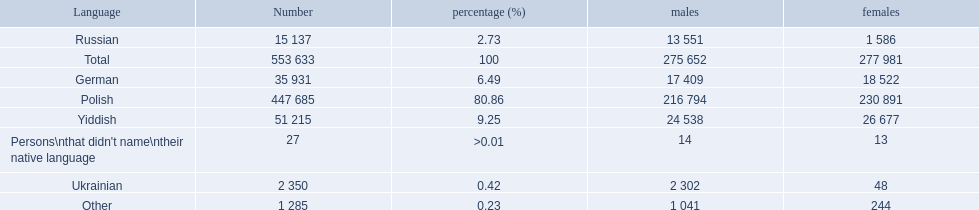What was the highest percentage of one language spoken by the plock governorate? 80.86. What language was spoken by 80.86 percent of the people? Polish. 